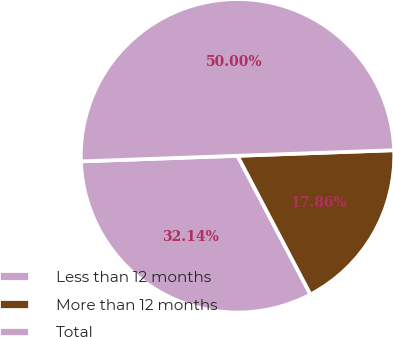Convert chart. <chart><loc_0><loc_0><loc_500><loc_500><pie_chart><fcel>Less than 12 months<fcel>More than 12 months<fcel>Total<nl><fcel>32.14%<fcel>17.86%<fcel>50.0%<nl></chart> 